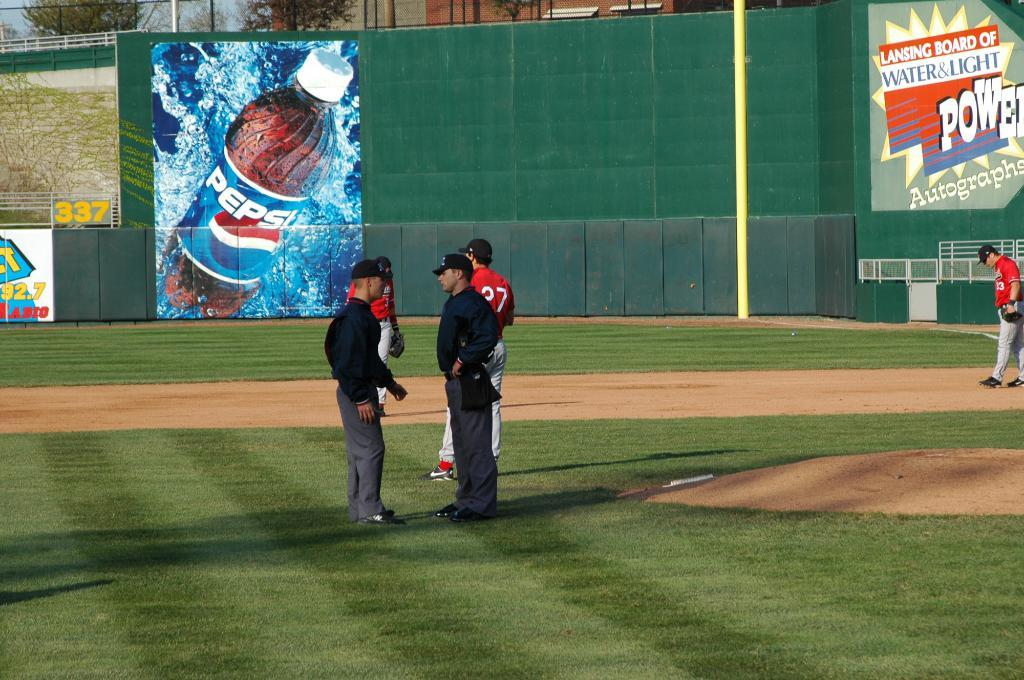<image>
Provide a brief description of the given image. Two men in black and grey uniforms are standing on a baseball field, talking, in front of a large Pepsi banner. 